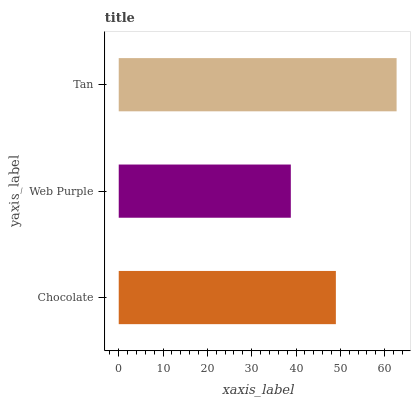Is Web Purple the minimum?
Answer yes or no. Yes. Is Tan the maximum?
Answer yes or no. Yes. Is Tan the minimum?
Answer yes or no. No. Is Web Purple the maximum?
Answer yes or no. No. Is Tan greater than Web Purple?
Answer yes or no. Yes. Is Web Purple less than Tan?
Answer yes or no. Yes. Is Web Purple greater than Tan?
Answer yes or no. No. Is Tan less than Web Purple?
Answer yes or no. No. Is Chocolate the high median?
Answer yes or no. Yes. Is Chocolate the low median?
Answer yes or no. Yes. Is Web Purple the high median?
Answer yes or no. No. Is Web Purple the low median?
Answer yes or no. No. 